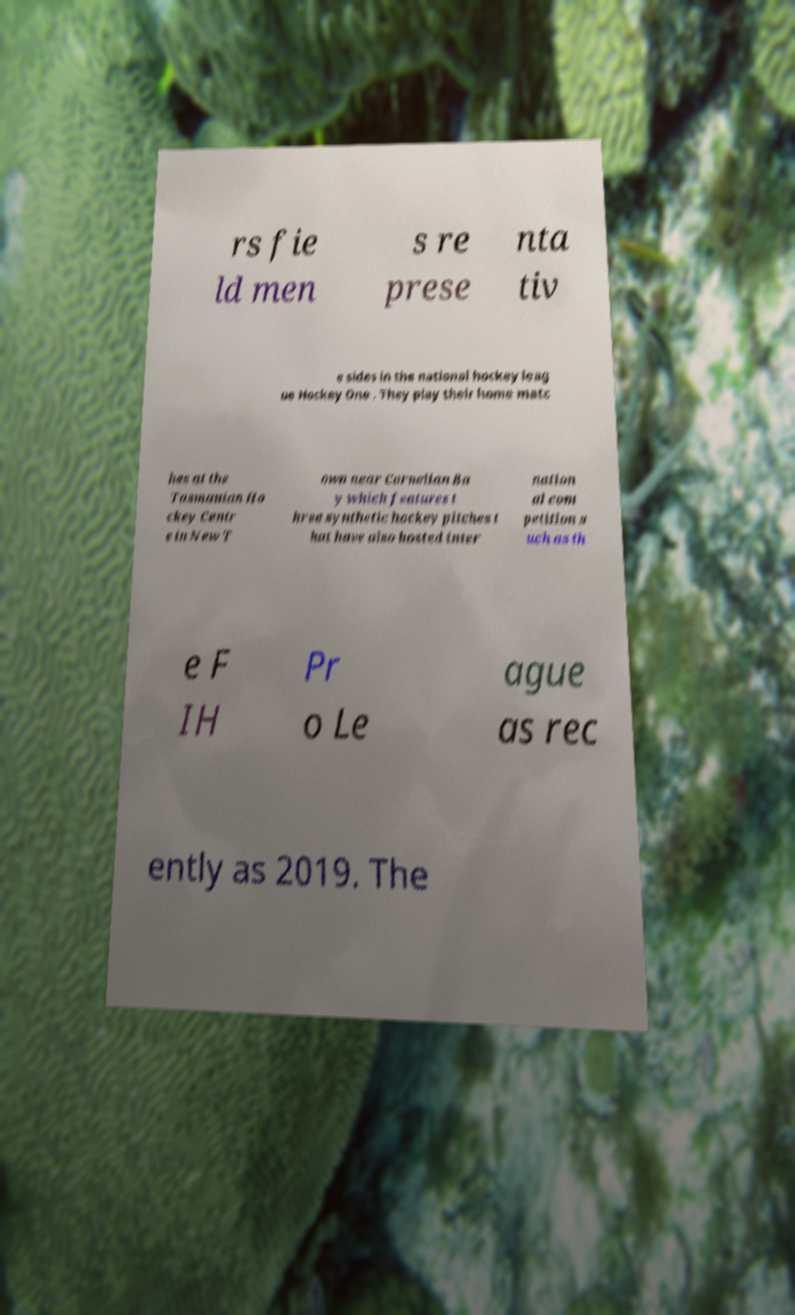Could you assist in decoding the text presented in this image and type it out clearly? rs fie ld men s re prese nta tiv e sides in the national hockey leag ue Hockey One . They play their home matc hes at the Tasmanian Ho ckey Centr e in New T own near Cornelian Ba y which features t hree synthetic hockey pitches t hat have also hosted inter nation al com petition s uch as th e F IH Pr o Le ague as rec ently as 2019. The 